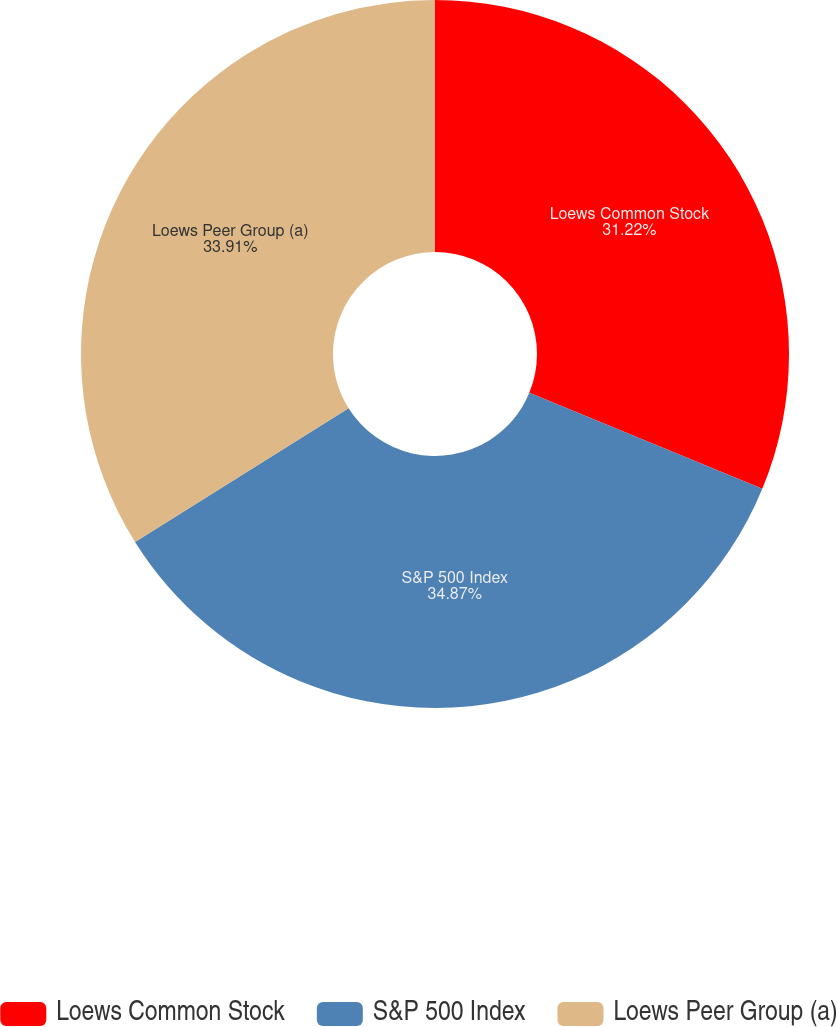<chart> <loc_0><loc_0><loc_500><loc_500><pie_chart><fcel>Loews Common Stock<fcel>S&P 500 Index<fcel>Loews Peer Group (a)<nl><fcel>31.22%<fcel>34.87%<fcel>33.91%<nl></chart> 